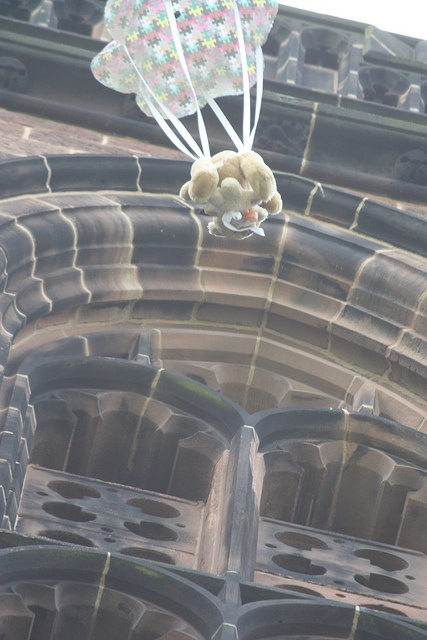Describe the objects in this image and their specific colors. I can see teddy bear in gray, ivory, darkgray, and tan tones and teddy bear in gray, darkgray, and lightgray tones in this image. 